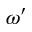<formula> <loc_0><loc_0><loc_500><loc_500>\omega ^ { \prime }</formula> 